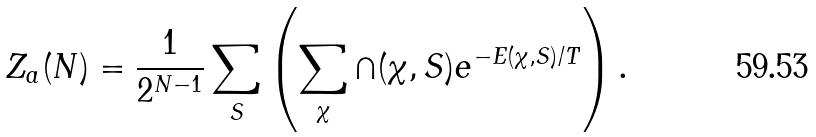Convert formula to latex. <formula><loc_0><loc_0><loc_500><loc_500>Z _ { a } ( N ) = \frac { 1 } { 2 ^ { N - 1 } } \sum _ { S } \left ( \sum _ { \chi } \cap ( \chi , { S } ) e ^ { - E ( \chi , { S } ) / T } \right ) .</formula> 